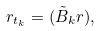<formula> <loc_0><loc_0><loc_500><loc_500>r _ { t _ { k } } = ( \tilde { B } _ { k } r ) ,</formula> 